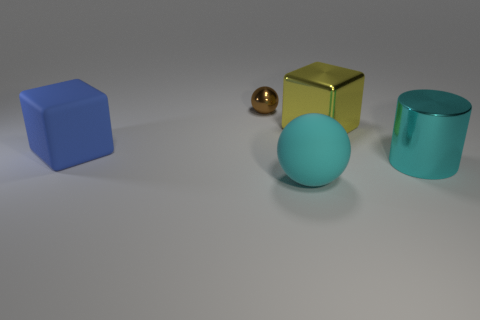Add 5 cyan matte balls. How many objects exist? 10 Subtract all cylinders. How many objects are left? 4 Add 3 tiny shiny objects. How many tiny shiny objects are left? 4 Add 4 yellow metallic things. How many yellow metallic things exist? 5 Subtract 0 blue spheres. How many objects are left? 5 Subtract all brown metal balls. Subtract all tiny blue rubber cubes. How many objects are left? 4 